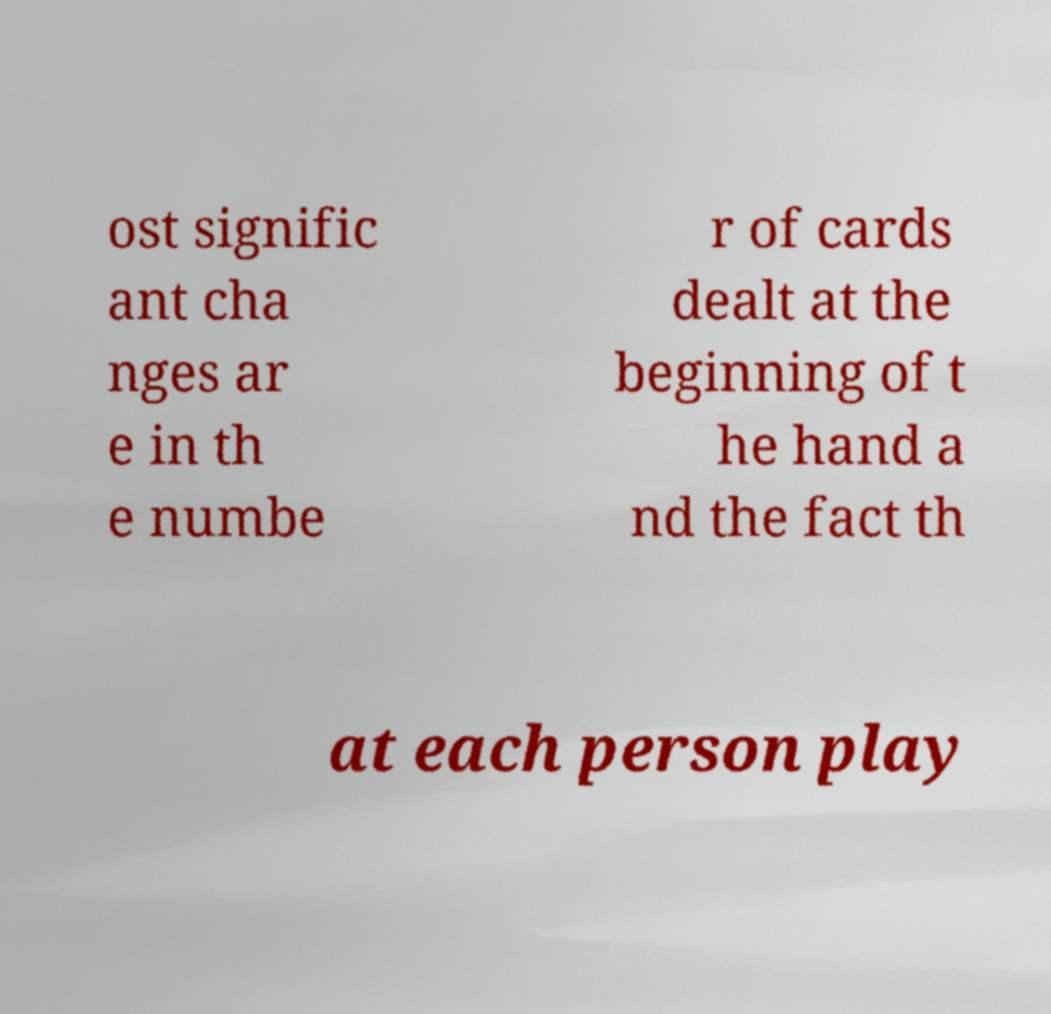Could you extract and type out the text from this image? ost signific ant cha nges ar e in th e numbe r of cards dealt at the beginning of t he hand a nd the fact th at each person play 